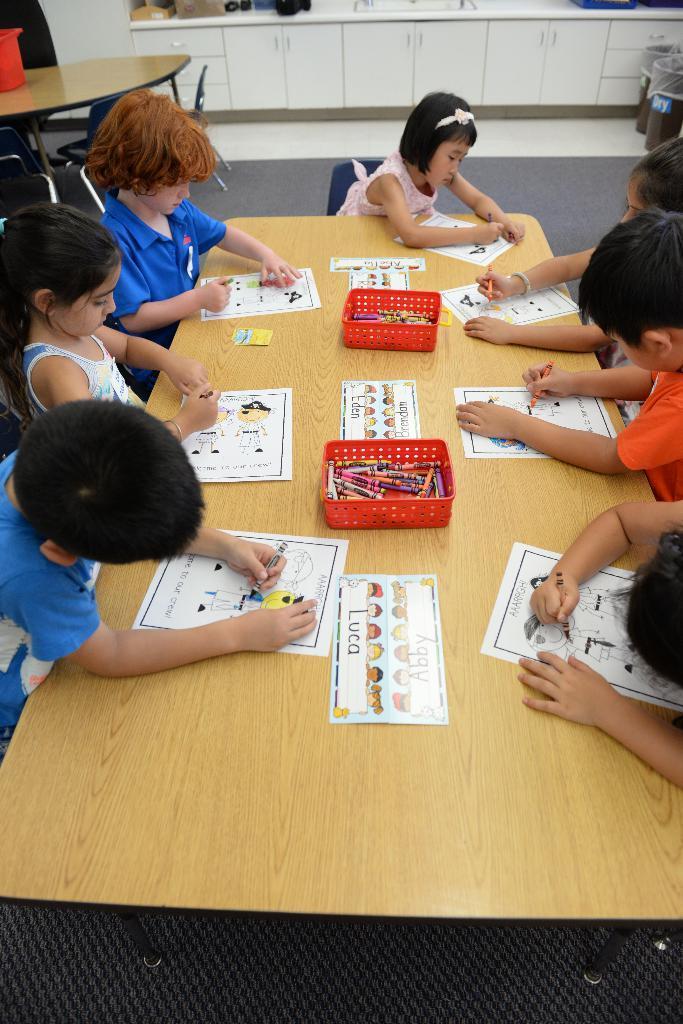Could you give a brief overview of what you see in this image? This picture shows few kids seated on the chairs and we see they are coloring pictures on the paper and we see couple of crayons baskets on the table and we see another table on the side. 